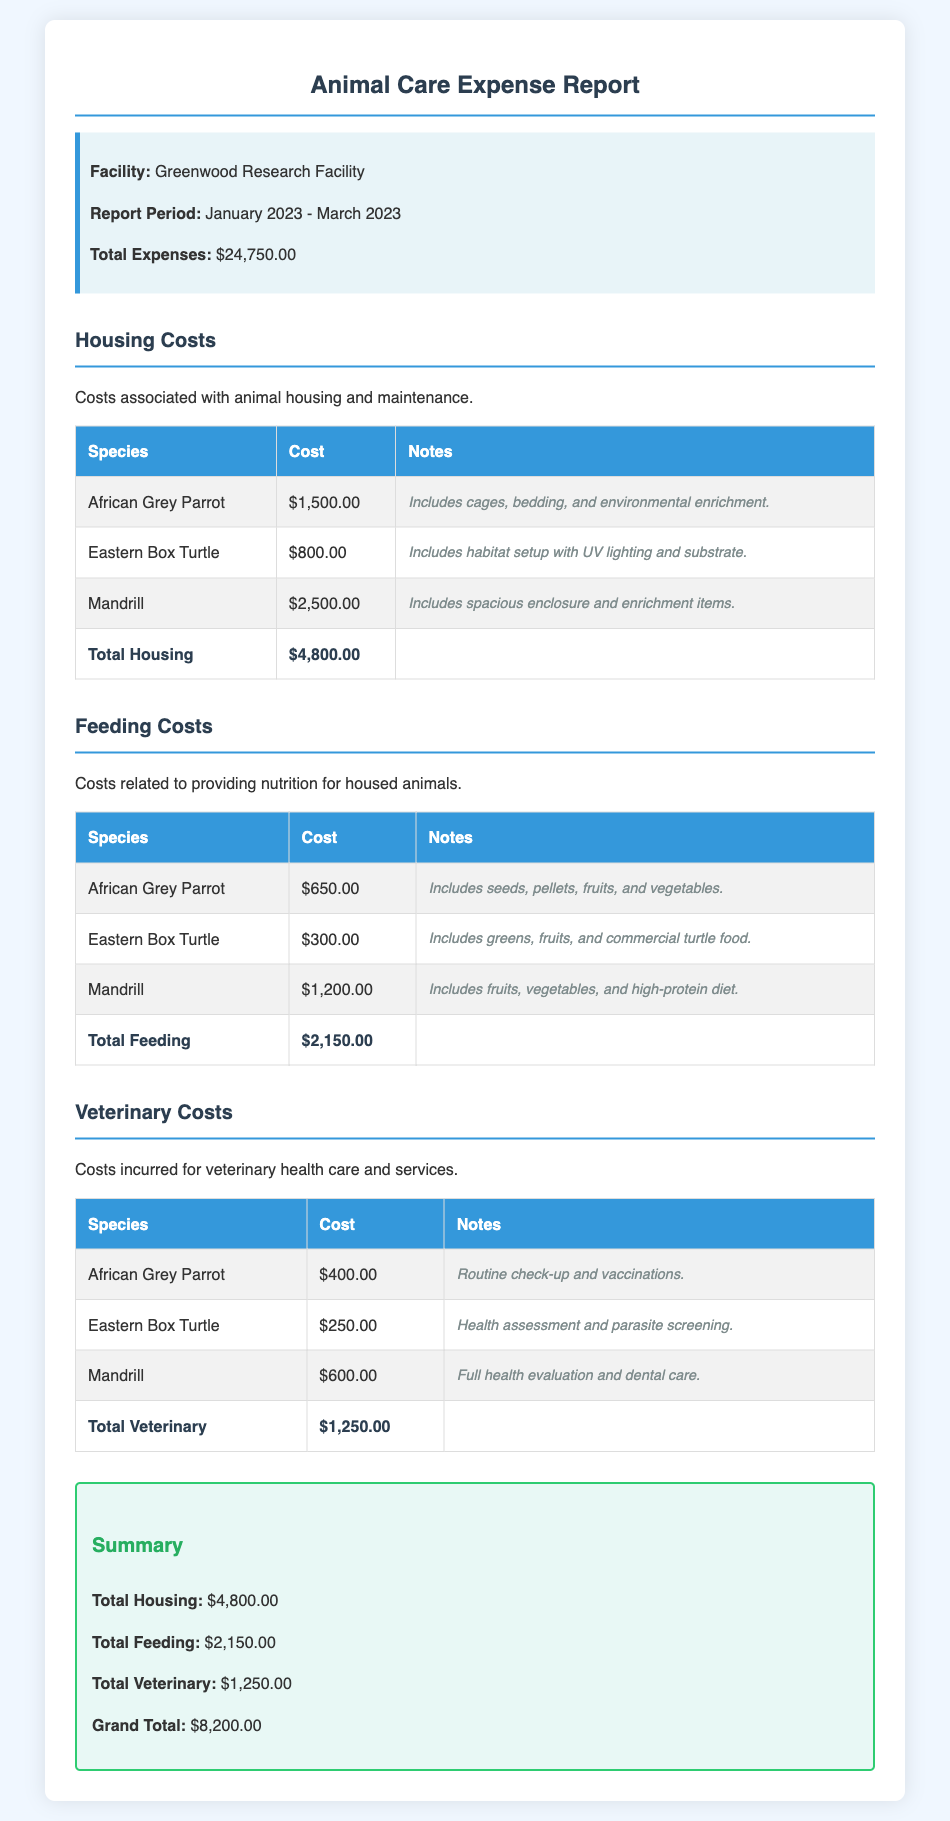What is the facility name? The facility name is explicitly stated in the document header as the Greenwood Research Facility.
Answer: Greenwood Research Facility What is the report period? The report period details the timeframe of the expenses, which is listed directly under the facility name as January 2023 - March 2023.
Answer: January 2023 - March 2023 What is the total expense amount? The total expenses are provided at the beginning of the document under the report information as $24,750.00.
Answer: $24,750.00 What are the total housing costs? The total housing costs are summarized in the document and calculated based on the individual housing expenses, amounting to $4,800.00.
Answer: $4,800.00 What is included in the veterinary costs for the Mandrill? The specific veterinary costs for the Mandrill are described in the notes under the veterinary table as a full health evaluation and dental care.
Answer: Full health evaluation and dental care What is the summary's grand total? The grand total in the summary section is calculated based on all expense categories, clearly stated as $8,200.00.
Answer: $8,200.00 How much is spent on feeding the Eastern Box Turtle? The feeding costs specifically for the Eastern Box Turtle are stated as $300.00 in the feeding section of the report.
Answer: $300.00 What species incurs the highest housing cost? The housing cost for the Mandrill is the highest among the listed species, specified as $2,500.00 in the housing costs table.
Answer: Mandrill 